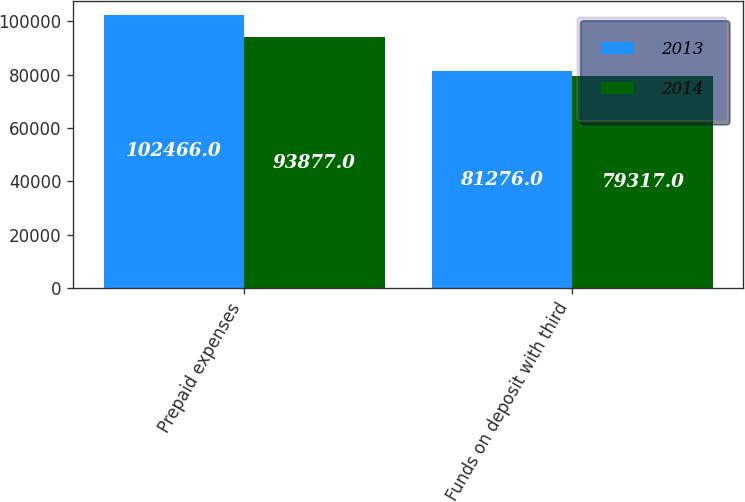<chart> <loc_0><loc_0><loc_500><loc_500><stacked_bar_chart><ecel><fcel>Prepaid expenses<fcel>Funds on deposit with third<nl><fcel>2013<fcel>102466<fcel>81276<nl><fcel>2014<fcel>93877<fcel>79317<nl></chart> 